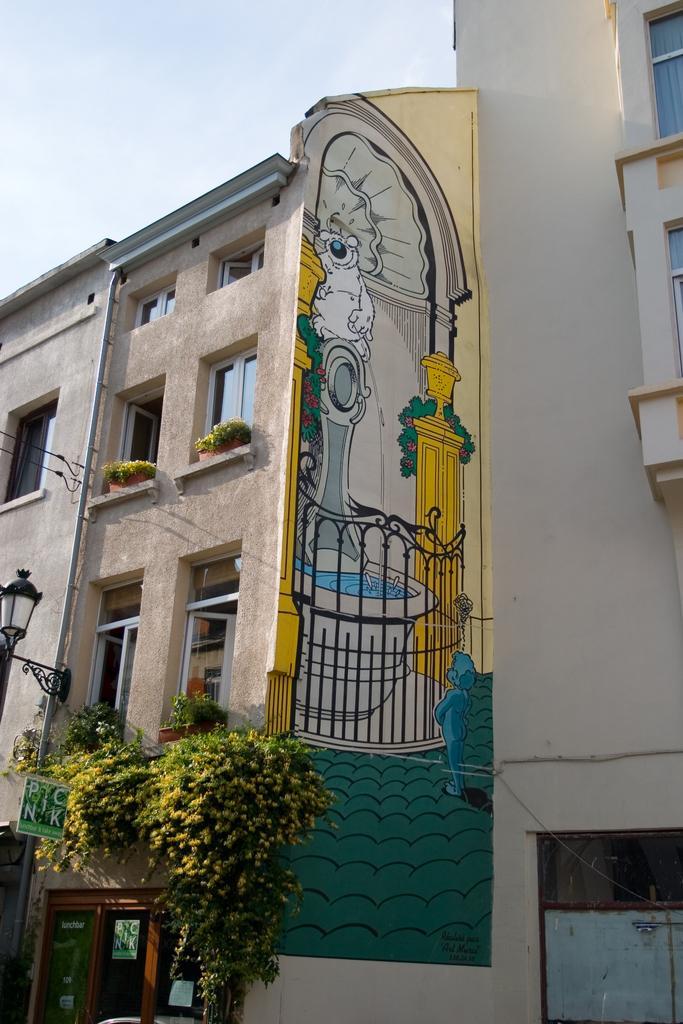Please provide a concise description of this image. In this picture we can see the buildings and on the building there is the painting, plants, windows, a pipe, a board and a light attached to the building. Behind the buildings there is the sky. 